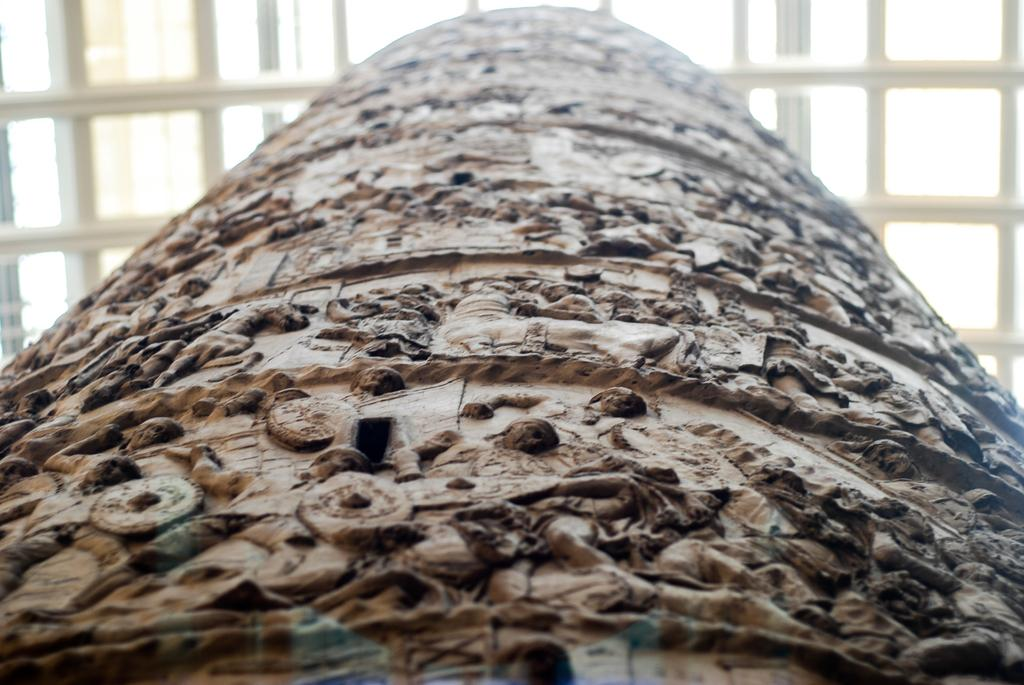What type of artwork is depicted in the image? There is a stone carving in the image. What can be seen in the background of the image? There is a grill in the background of the image. What is the purpose of the tramp in the image? There is no tramp present in the image. Is there a bear visible in the image? No, there is no bear present in the image. 